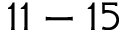<formula> <loc_0><loc_0><loc_500><loc_500>1 1 - 1 5</formula> 